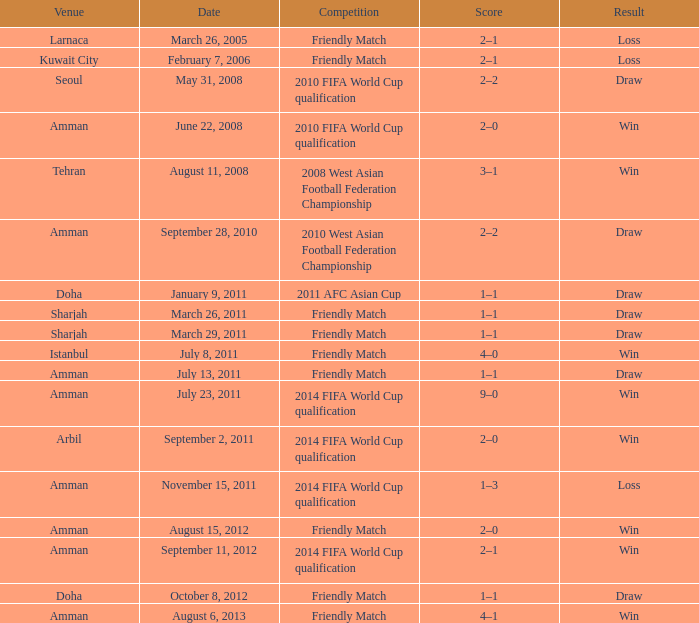What was the name of the competition that took place on may 31, 2008? 2010 FIFA World Cup qualification. 